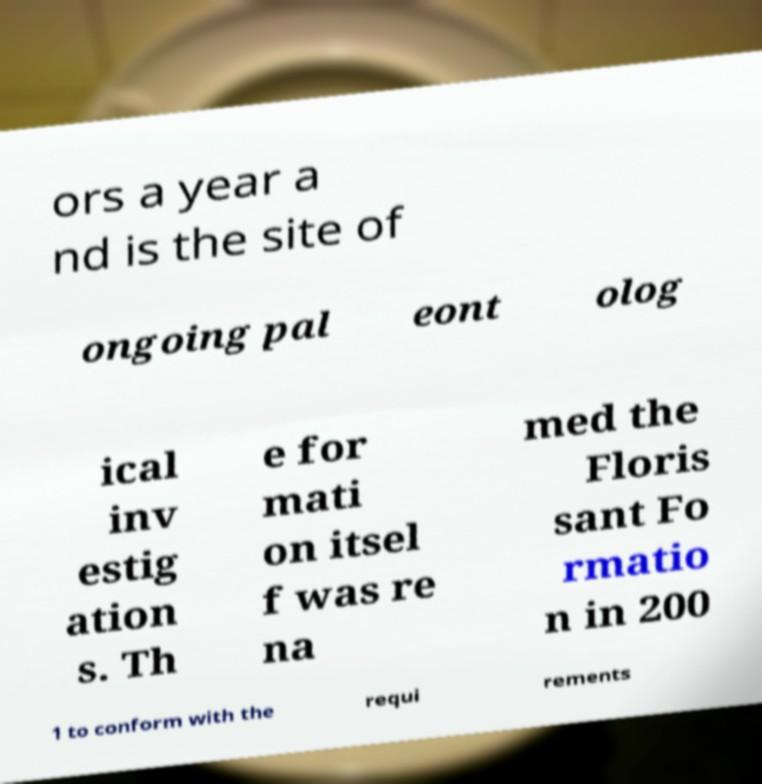Could you assist in decoding the text presented in this image and type it out clearly? ors a year a nd is the site of ongoing pal eont olog ical inv estig ation s. Th e for mati on itsel f was re na med the Floris sant Fo rmatio n in 200 1 to conform with the requi rements 